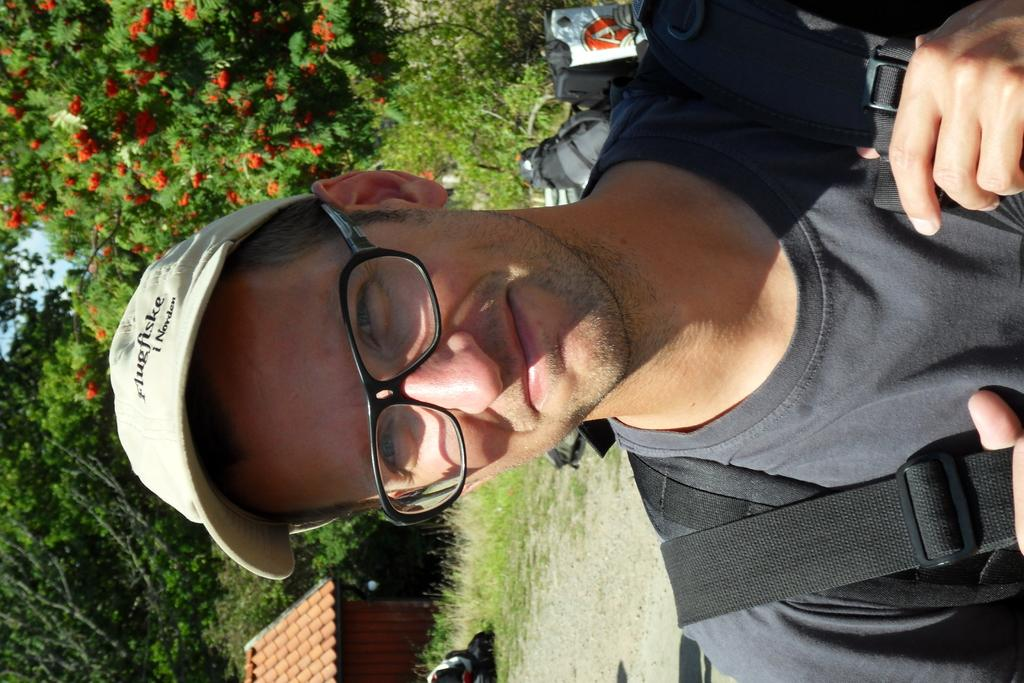Who is the main subject in the image? There is a person in the center of the image. What is the person wearing? The person is wearing a bag. What can be seen in the background of the image? There is a house, trees, plants, grass, a road, and the sky visible in the background of the image. What type of vegetable is being harvested in the image? There is no vegetable being harvested in the image; the image does not depict any farming or harvesting activities. 